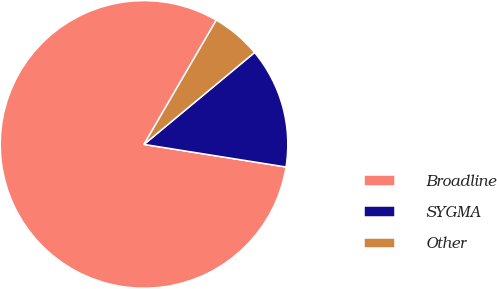Convert chart. <chart><loc_0><loc_0><loc_500><loc_500><pie_chart><fcel>Broadline<fcel>SYGMA<fcel>Other<nl><fcel>80.88%<fcel>13.55%<fcel>5.58%<nl></chart> 